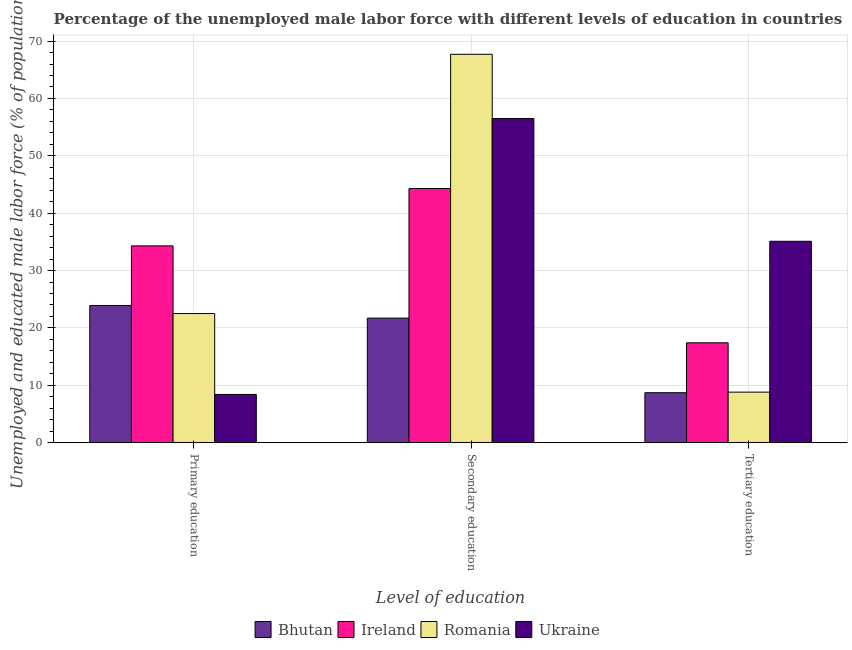How many groups of bars are there?
Your answer should be very brief. 3. Are the number of bars on each tick of the X-axis equal?
Your response must be concise. Yes. How many bars are there on the 2nd tick from the left?
Your response must be concise. 4. What is the label of the 3rd group of bars from the left?
Keep it short and to the point. Tertiary education. What is the percentage of male labor force who received secondary education in Romania?
Provide a succinct answer. 67.7. Across all countries, what is the maximum percentage of male labor force who received secondary education?
Keep it short and to the point. 67.7. Across all countries, what is the minimum percentage of male labor force who received secondary education?
Give a very brief answer. 21.7. In which country was the percentage of male labor force who received primary education maximum?
Make the answer very short. Ireland. In which country was the percentage of male labor force who received secondary education minimum?
Your answer should be very brief. Bhutan. What is the total percentage of male labor force who received primary education in the graph?
Provide a short and direct response. 89.1. What is the difference between the percentage of male labor force who received primary education in Bhutan and that in Ukraine?
Your answer should be very brief. 15.5. What is the difference between the percentage of male labor force who received primary education in Bhutan and the percentage of male labor force who received tertiary education in Ukraine?
Offer a terse response. -11.2. What is the average percentage of male labor force who received secondary education per country?
Offer a terse response. 47.55. What is the difference between the percentage of male labor force who received tertiary education and percentage of male labor force who received primary education in Ireland?
Your answer should be very brief. -16.9. What is the ratio of the percentage of male labor force who received secondary education in Bhutan to that in Romania?
Offer a terse response. 0.32. Is the difference between the percentage of male labor force who received secondary education in Ireland and Romania greater than the difference between the percentage of male labor force who received tertiary education in Ireland and Romania?
Ensure brevity in your answer.  No. What is the difference between the highest and the second highest percentage of male labor force who received tertiary education?
Provide a succinct answer. 17.7. What is the difference between the highest and the lowest percentage of male labor force who received primary education?
Ensure brevity in your answer.  25.9. In how many countries, is the percentage of male labor force who received primary education greater than the average percentage of male labor force who received primary education taken over all countries?
Offer a terse response. 3. Is the sum of the percentage of male labor force who received tertiary education in Bhutan and Romania greater than the maximum percentage of male labor force who received primary education across all countries?
Make the answer very short. No. What does the 1st bar from the left in Secondary education represents?
Offer a terse response. Bhutan. What does the 2nd bar from the right in Tertiary education represents?
Your response must be concise. Romania. Is it the case that in every country, the sum of the percentage of male labor force who received primary education and percentage of male labor force who received secondary education is greater than the percentage of male labor force who received tertiary education?
Ensure brevity in your answer.  Yes. Are all the bars in the graph horizontal?
Offer a terse response. No. How many countries are there in the graph?
Make the answer very short. 4. What is the difference between two consecutive major ticks on the Y-axis?
Keep it short and to the point. 10. Are the values on the major ticks of Y-axis written in scientific E-notation?
Your answer should be compact. No. Does the graph contain any zero values?
Provide a short and direct response. No. How are the legend labels stacked?
Keep it short and to the point. Horizontal. What is the title of the graph?
Offer a terse response. Percentage of the unemployed male labor force with different levels of education in countries. What is the label or title of the X-axis?
Make the answer very short. Level of education. What is the label or title of the Y-axis?
Make the answer very short. Unemployed and educated male labor force (% of population). What is the Unemployed and educated male labor force (% of population) of Bhutan in Primary education?
Your answer should be compact. 23.9. What is the Unemployed and educated male labor force (% of population) of Ireland in Primary education?
Offer a terse response. 34.3. What is the Unemployed and educated male labor force (% of population) in Ukraine in Primary education?
Provide a succinct answer. 8.4. What is the Unemployed and educated male labor force (% of population) of Bhutan in Secondary education?
Offer a terse response. 21.7. What is the Unemployed and educated male labor force (% of population) in Ireland in Secondary education?
Ensure brevity in your answer.  44.3. What is the Unemployed and educated male labor force (% of population) of Romania in Secondary education?
Offer a terse response. 67.7. What is the Unemployed and educated male labor force (% of population) in Ukraine in Secondary education?
Offer a very short reply. 56.5. What is the Unemployed and educated male labor force (% of population) of Bhutan in Tertiary education?
Your answer should be very brief. 8.7. What is the Unemployed and educated male labor force (% of population) of Ireland in Tertiary education?
Make the answer very short. 17.4. What is the Unemployed and educated male labor force (% of population) of Romania in Tertiary education?
Make the answer very short. 8.8. What is the Unemployed and educated male labor force (% of population) of Ukraine in Tertiary education?
Make the answer very short. 35.1. Across all Level of education, what is the maximum Unemployed and educated male labor force (% of population) of Bhutan?
Provide a succinct answer. 23.9. Across all Level of education, what is the maximum Unemployed and educated male labor force (% of population) of Ireland?
Give a very brief answer. 44.3. Across all Level of education, what is the maximum Unemployed and educated male labor force (% of population) in Romania?
Ensure brevity in your answer.  67.7. Across all Level of education, what is the maximum Unemployed and educated male labor force (% of population) of Ukraine?
Give a very brief answer. 56.5. Across all Level of education, what is the minimum Unemployed and educated male labor force (% of population) of Bhutan?
Provide a short and direct response. 8.7. Across all Level of education, what is the minimum Unemployed and educated male labor force (% of population) in Ireland?
Keep it short and to the point. 17.4. Across all Level of education, what is the minimum Unemployed and educated male labor force (% of population) of Romania?
Make the answer very short. 8.8. Across all Level of education, what is the minimum Unemployed and educated male labor force (% of population) in Ukraine?
Offer a very short reply. 8.4. What is the total Unemployed and educated male labor force (% of population) in Bhutan in the graph?
Provide a short and direct response. 54.3. What is the total Unemployed and educated male labor force (% of population) of Ireland in the graph?
Your answer should be compact. 96. What is the total Unemployed and educated male labor force (% of population) of Romania in the graph?
Your answer should be very brief. 99. What is the total Unemployed and educated male labor force (% of population) in Ukraine in the graph?
Provide a succinct answer. 100. What is the difference between the Unemployed and educated male labor force (% of population) of Bhutan in Primary education and that in Secondary education?
Your answer should be compact. 2.2. What is the difference between the Unemployed and educated male labor force (% of population) in Ireland in Primary education and that in Secondary education?
Provide a short and direct response. -10. What is the difference between the Unemployed and educated male labor force (% of population) of Romania in Primary education and that in Secondary education?
Keep it short and to the point. -45.2. What is the difference between the Unemployed and educated male labor force (% of population) in Ukraine in Primary education and that in Secondary education?
Your answer should be very brief. -48.1. What is the difference between the Unemployed and educated male labor force (% of population) of Ireland in Primary education and that in Tertiary education?
Your answer should be very brief. 16.9. What is the difference between the Unemployed and educated male labor force (% of population) of Ukraine in Primary education and that in Tertiary education?
Make the answer very short. -26.7. What is the difference between the Unemployed and educated male labor force (% of population) of Ireland in Secondary education and that in Tertiary education?
Offer a terse response. 26.9. What is the difference between the Unemployed and educated male labor force (% of population) of Romania in Secondary education and that in Tertiary education?
Offer a terse response. 58.9. What is the difference between the Unemployed and educated male labor force (% of population) in Ukraine in Secondary education and that in Tertiary education?
Keep it short and to the point. 21.4. What is the difference between the Unemployed and educated male labor force (% of population) in Bhutan in Primary education and the Unemployed and educated male labor force (% of population) in Ireland in Secondary education?
Your answer should be compact. -20.4. What is the difference between the Unemployed and educated male labor force (% of population) in Bhutan in Primary education and the Unemployed and educated male labor force (% of population) in Romania in Secondary education?
Make the answer very short. -43.8. What is the difference between the Unemployed and educated male labor force (% of population) of Bhutan in Primary education and the Unemployed and educated male labor force (% of population) of Ukraine in Secondary education?
Offer a very short reply. -32.6. What is the difference between the Unemployed and educated male labor force (% of population) in Ireland in Primary education and the Unemployed and educated male labor force (% of population) in Romania in Secondary education?
Your answer should be very brief. -33.4. What is the difference between the Unemployed and educated male labor force (% of population) in Ireland in Primary education and the Unemployed and educated male labor force (% of population) in Ukraine in Secondary education?
Ensure brevity in your answer.  -22.2. What is the difference between the Unemployed and educated male labor force (% of population) in Romania in Primary education and the Unemployed and educated male labor force (% of population) in Ukraine in Secondary education?
Your answer should be very brief. -34. What is the difference between the Unemployed and educated male labor force (% of population) in Bhutan in Primary education and the Unemployed and educated male labor force (% of population) in Romania in Tertiary education?
Offer a terse response. 15.1. What is the difference between the Unemployed and educated male labor force (% of population) in Ireland in Primary education and the Unemployed and educated male labor force (% of population) in Romania in Tertiary education?
Keep it short and to the point. 25.5. What is the difference between the Unemployed and educated male labor force (% of population) of Romania in Primary education and the Unemployed and educated male labor force (% of population) of Ukraine in Tertiary education?
Your answer should be very brief. -12.6. What is the difference between the Unemployed and educated male labor force (% of population) in Bhutan in Secondary education and the Unemployed and educated male labor force (% of population) in Ireland in Tertiary education?
Offer a very short reply. 4.3. What is the difference between the Unemployed and educated male labor force (% of population) in Ireland in Secondary education and the Unemployed and educated male labor force (% of population) in Romania in Tertiary education?
Ensure brevity in your answer.  35.5. What is the difference between the Unemployed and educated male labor force (% of population) of Ireland in Secondary education and the Unemployed and educated male labor force (% of population) of Ukraine in Tertiary education?
Your answer should be very brief. 9.2. What is the difference between the Unemployed and educated male labor force (% of population) in Romania in Secondary education and the Unemployed and educated male labor force (% of population) in Ukraine in Tertiary education?
Your answer should be very brief. 32.6. What is the average Unemployed and educated male labor force (% of population) in Ireland per Level of education?
Your response must be concise. 32. What is the average Unemployed and educated male labor force (% of population) in Ukraine per Level of education?
Offer a terse response. 33.33. What is the difference between the Unemployed and educated male labor force (% of population) in Bhutan and Unemployed and educated male labor force (% of population) in Ireland in Primary education?
Your response must be concise. -10.4. What is the difference between the Unemployed and educated male labor force (% of population) of Ireland and Unemployed and educated male labor force (% of population) of Romania in Primary education?
Provide a short and direct response. 11.8. What is the difference between the Unemployed and educated male labor force (% of population) in Ireland and Unemployed and educated male labor force (% of population) in Ukraine in Primary education?
Provide a short and direct response. 25.9. What is the difference between the Unemployed and educated male labor force (% of population) in Bhutan and Unemployed and educated male labor force (% of population) in Ireland in Secondary education?
Your answer should be compact. -22.6. What is the difference between the Unemployed and educated male labor force (% of population) in Bhutan and Unemployed and educated male labor force (% of population) in Romania in Secondary education?
Provide a short and direct response. -46. What is the difference between the Unemployed and educated male labor force (% of population) in Bhutan and Unemployed and educated male labor force (% of population) in Ukraine in Secondary education?
Your answer should be compact. -34.8. What is the difference between the Unemployed and educated male labor force (% of population) of Ireland and Unemployed and educated male labor force (% of population) of Romania in Secondary education?
Offer a terse response. -23.4. What is the difference between the Unemployed and educated male labor force (% of population) in Ireland and Unemployed and educated male labor force (% of population) in Ukraine in Secondary education?
Offer a very short reply. -12.2. What is the difference between the Unemployed and educated male labor force (% of population) of Romania and Unemployed and educated male labor force (% of population) of Ukraine in Secondary education?
Your answer should be very brief. 11.2. What is the difference between the Unemployed and educated male labor force (% of population) of Bhutan and Unemployed and educated male labor force (% of population) of Ukraine in Tertiary education?
Keep it short and to the point. -26.4. What is the difference between the Unemployed and educated male labor force (% of population) of Ireland and Unemployed and educated male labor force (% of population) of Ukraine in Tertiary education?
Offer a terse response. -17.7. What is the difference between the Unemployed and educated male labor force (% of population) in Romania and Unemployed and educated male labor force (% of population) in Ukraine in Tertiary education?
Your answer should be compact. -26.3. What is the ratio of the Unemployed and educated male labor force (% of population) of Bhutan in Primary education to that in Secondary education?
Your answer should be very brief. 1.1. What is the ratio of the Unemployed and educated male labor force (% of population) in Ireland in Primary education to that in Secondary education?
Offer a very short reply. 0.77. What is the ratio of the Unemployed and educated male labor force (% of population) in Romania in Primary education to that in Secondary education?
Offer a very short reply. 0.33. What is the ratio of the Unemployed and educated male labor force (% of population) in Ukraine in Primary education to that in Secondary education?
Make the answer very short. 0.15. What is the ratio of the Unemployed and educated male labor force (% of population) in Bhutan in Primary education to that in Tertiary education?
Your response must be concise. 2.75. What is the ratio of the Unemployed and educated male labor force (% of population) in Ireland in Primary education to that in Tertiary education?
Give a very brief answer. 1.97. What is the ratio of the Unemployed and educated male labor force (% of population) in Romania in Primary education to that in Tertiary education?
Provide a succinct answer. 2.56. What is the ratio of the Unemployed and educated male labor force (% of population) in Ukraine in Primary education to that in Tertiary education?
Offer a very short reply. 0.24. What is the ratio of the Unemployed and educated male labor force (% of population) in Bhutan in Secondary education to that in Tertiary education?
Ensure brevity in your answer.  2.49. What is the ratio of the Unemployed and educated male labor force (% of population) of Ireland in Secondary education to that in Tertiary education?
Keep it short and to the point. 2.55. What is the ratio of the Unemployed and educated male labor force (% of population) in Romania in Secondary education to that in Tertiary education?
Offer a very short reply. 7.69. What is the ratio of the Unemployed and educated male labor force (% of population) in Ukraine in Secondary education to that in Tertiary education?
Make the answer very short. 1.61. What is the difference between the highest and the second highest Unemployed and educated male labor force (% of population) of Romania?
Give a very brief answer. 45.2. What is the difference between the highest and the second highest Unemployed and educated male labor force (% of population) of Ukraine?
Keep it short and to the point. 21.4. What is the difference between the highest and the lowest Unemployed and educated male labor force (% of population) of Ireland?
Provide a short and direct response. 26.9. What is the difference between the highest and the lowest Unemployed and educated male labor force (% of population) of Romania?
Give a very brief answer. 58.9. What is the difference between the highest and the lowest Unemployed and educated male labor force (% of population) of Ukraine?
Provide a short and direct response. 48.1. 